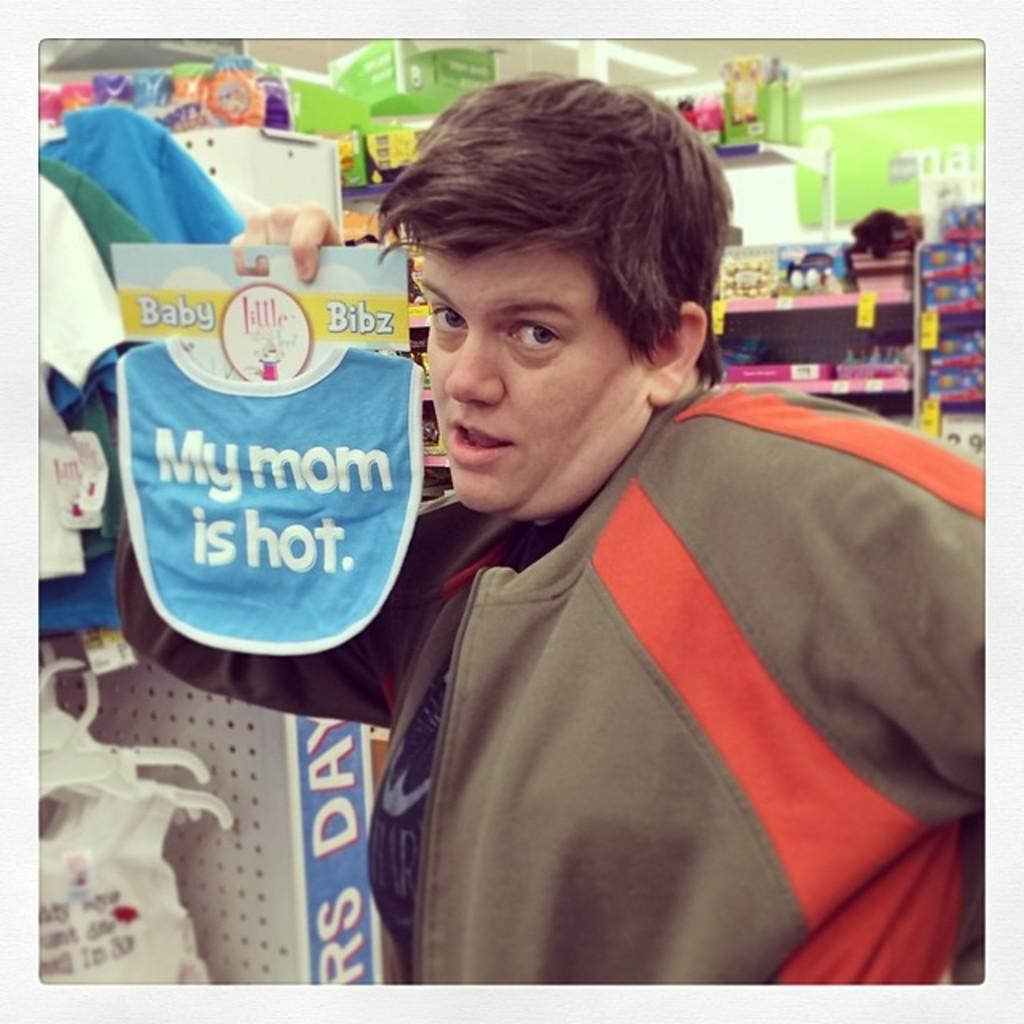<image>
Present a compact description of the photo's key features. A man wearing a brown shirt is holding up a bib that says "my mom is hot". 